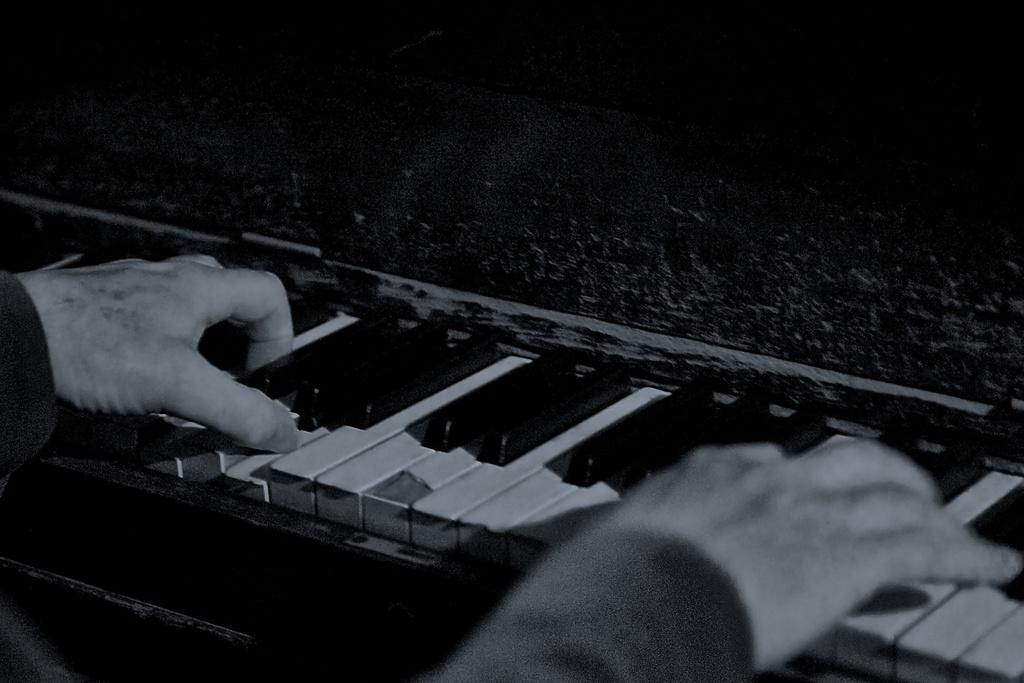What is the main subject of the image? There is a person in the image. What is the person doing in the image? The person is playing a keyboard. Where is the keyboard located in the image? The keyboard is on the left side of the image. What type of underwear is the person wearing in the image? There is no information about the person's underwear in the image, so it cannot be determined. 